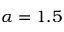<formula> <loc_0><loc_0><loc_500><loc_500>\alpha = 1 . 5</formula> 